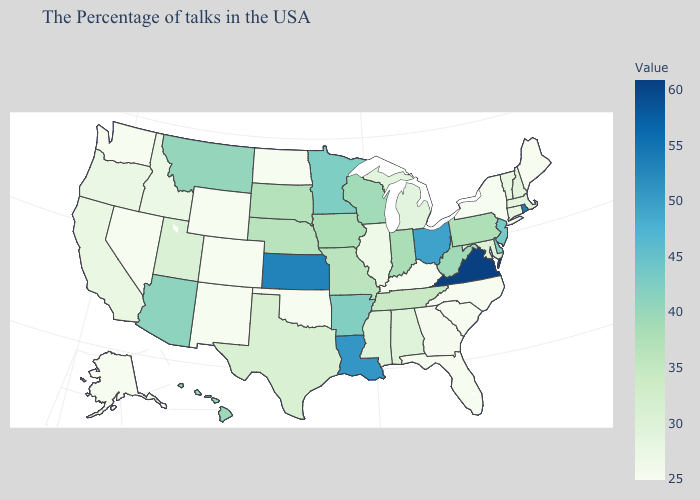Does Arizona have the highest value in the West?
Keep it brief. Yes. Does Maine have the highest value in the Northeast?
Concise answer only. No. Among the states that border Indiana , which have the highest value?
Short answer required. Ohio. Does Virginia have the highest value in the USA?
Keep it brief. Yes. Which states have the highest value in the USA?
Give a very brief answer. Virginia. 